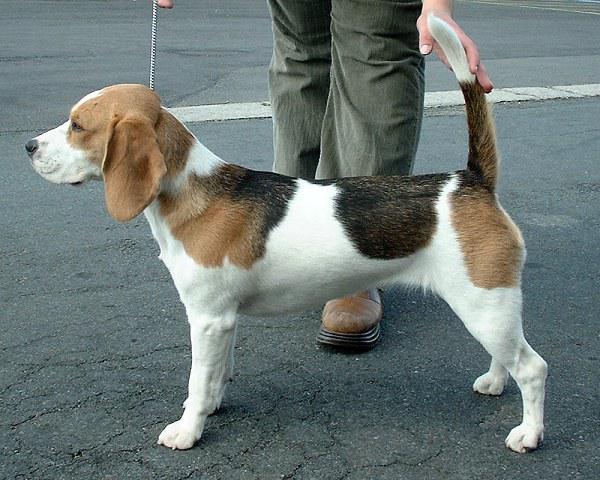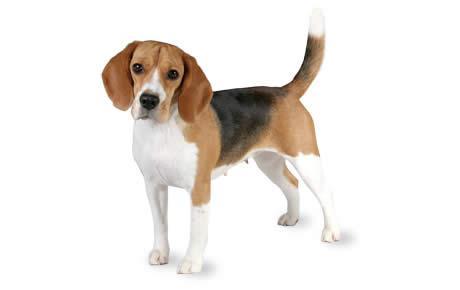The first image is the image on the left, the second image is the image on the right. Assess this claim about the two images: "The dog in the image on the left is wearing a leash.". Correct or not? Answer yes or no. Yes. 